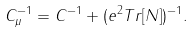<formula> <loc_0><loc_0><loc_500><loc_500>C ^ { - 1 } _ { \mu } = C ^ { - 1 } + ( e ^ { 2 } T r [ { N } ] ) ^ { - 1 } .</formula> 